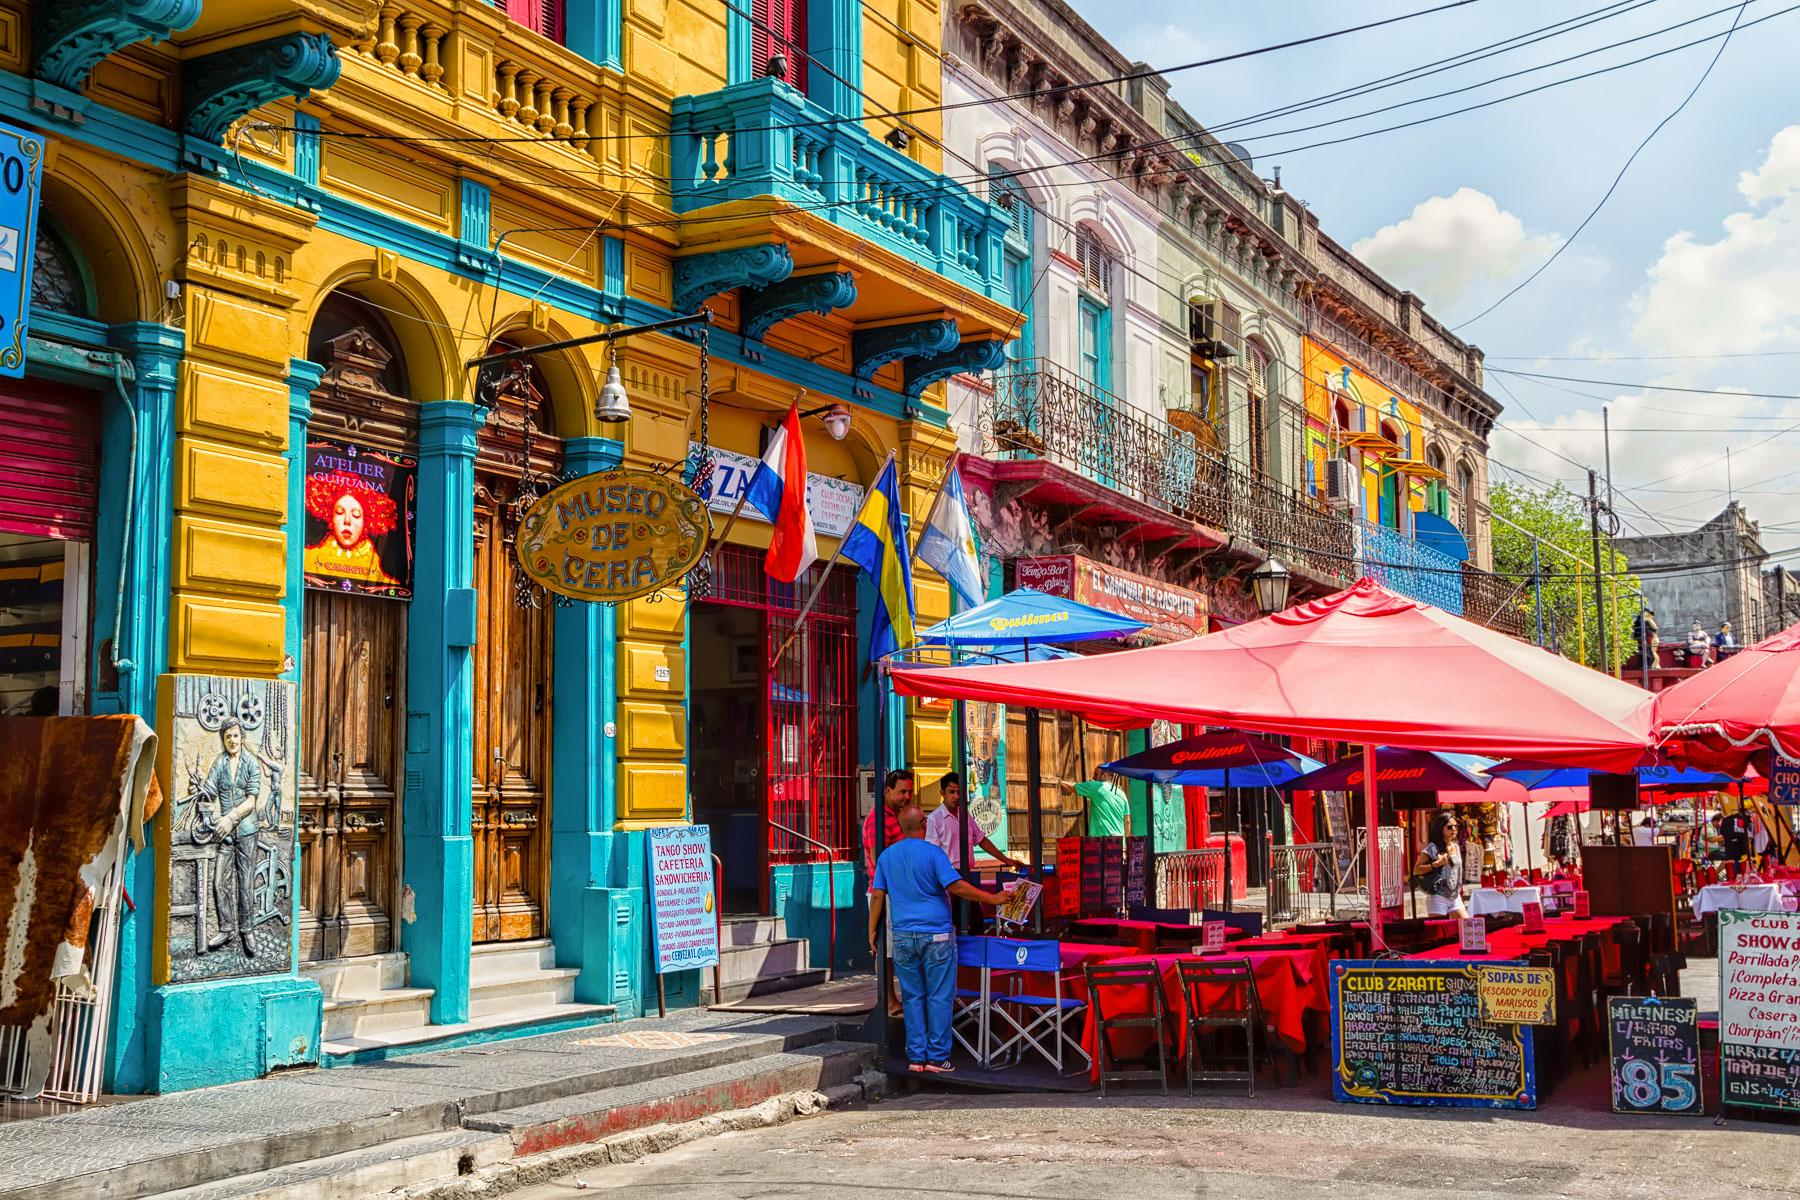Can you describe the main features of this image for me? The image portrays a lively and colorful street scene in La Boca, a vibrant neighborhood in Buenos Aires, Argentina. Dominating the scene are buildings adorned with vivid hues of yellow, blue, and red, radiating an energetic and cheerful ambiance. Street vendors and an outdoor seating area for a restaurant with red umbrellas are visible, adding to the bustling environment. Flags and signs, including ones for a wax museum and a tango show, underscore the cultural vibrancy of the area. The detailed architecture, featuring balconies and ornate designs, hints at the historical and artistic significance of the neighborhood. This image encapsulates the unique charm and lively spirit of La Boca, making it a memorable portrayal of life in Buenos Aires. 